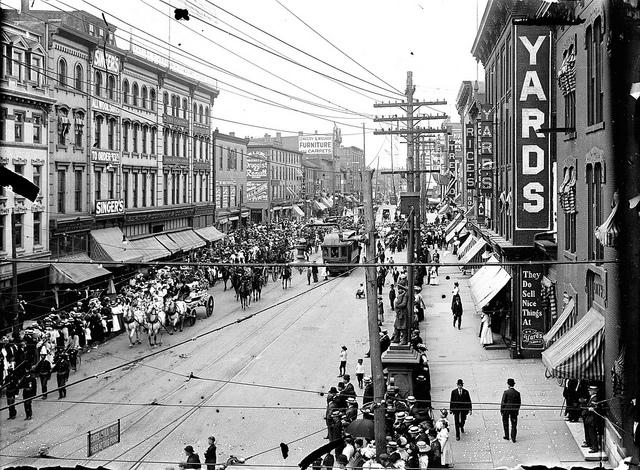What is written on the right?
Answer briefly. Yards. Are there any cars?
Write a very short answer. No. Is there any color in this photo?
Short answer required. No. 